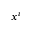Convert formula to latex. <formula><loc_0><loc_0><loc_500><loc_500>x ^ { i }</formula> 